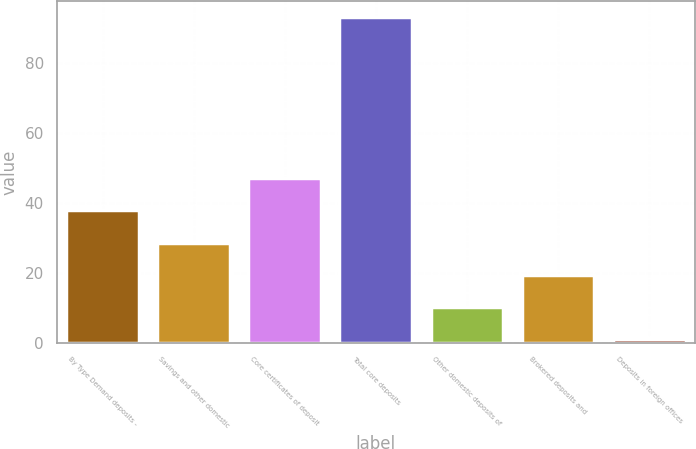Convert chart to OTSL. <chart><loc_0><loc_0><loc_500><loc_500><bar_chart><fcel>By Type Demand deposits -<fcel>Savings and other domestic<fcel>Core certificates of deposit<fcel>Total core deposits<fcel>Other domestic deposits of<fcel>Brokered deposits and<fcel>Deposits in foreign offices<nl><fcel>37.8<fcel>28.6<fcel>47<fcel>93<fcel>10.2<fcel>19.4<fcel>1<nl></chart> 